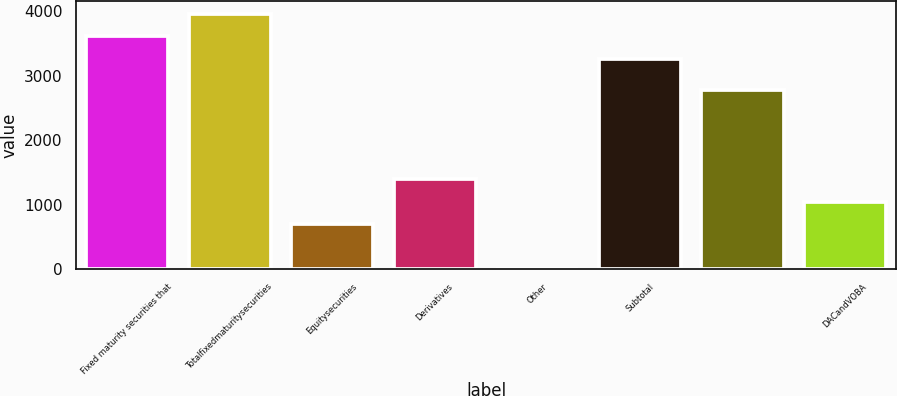Convert chart to OTSL. <chart><loc_0><loc_0><loc_500><loc_500><bar_chart><fcel>Fixed maturity securities that<fcel>Totalfixedmaturitysecurities<fcel>Equitysecurities<fcel>Derivatives<fcel>Other<fcel>Subtotal<fcel>Unnamed: 6<fcel>DACandVOBA<nl><fcel>3615.6<fcel>3963.2<fcel>698.2<fcel>1393.4<fcel>3<fcel>3268<fcel>2783.8<fcel>1045.8<nl></chart> 